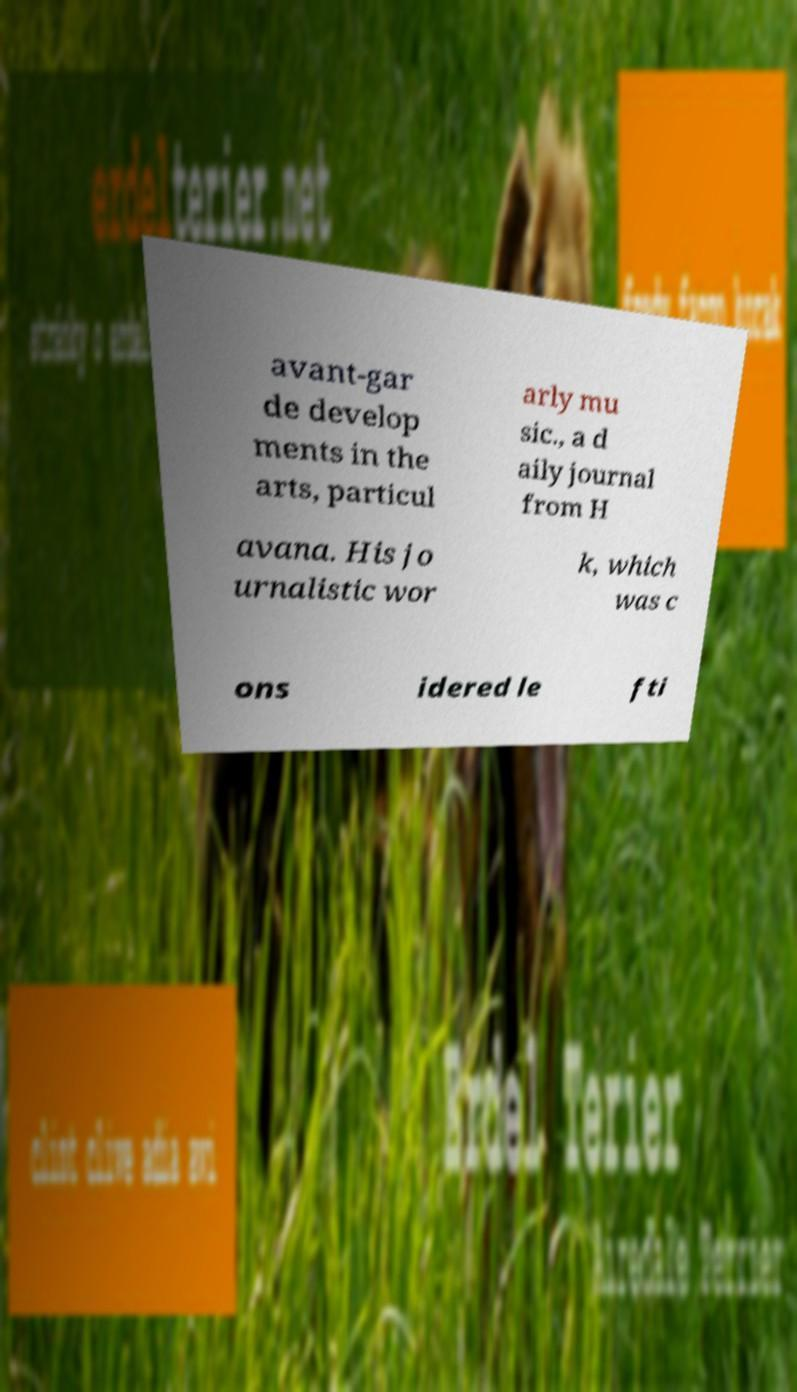Can you accurately transcribe the text from the provided image for me? avant-gar de develop ments in the arts, particul arly mu sic., a d aily journal from H avana. His jo urnalistic wor k, which was c ons idered le fti 